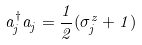<formula> <loc_0><loc_0><loc_500><loc_500>a _ { j } ^ { \dagger } a _ { j } = \frac { 1 } { 2 } ( \sigma _ { j } ^ { z } + 1 )</formula> 